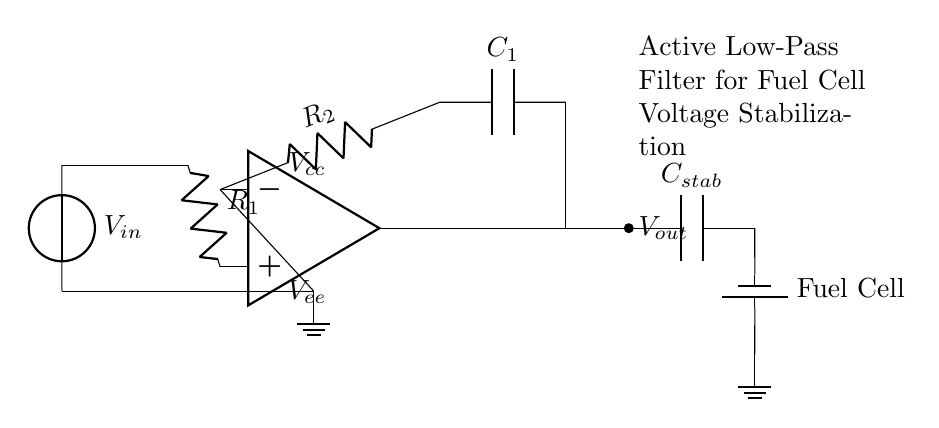What is the input voltage labeled in the circuit? The input voltage is labeled as V_in, which is typically the voltage supplied to the filter circuit.
Answer: V_in What are the components in the feedback network? The feedback network contains a resistor labeled R_2 and a capacitor labeled C_1, showing the components involved in feedback stabilization.
Answer: R_2, C_1 What is the output voltage of this circuit? The output voltage is labeled as V_out, indicating the voltage that is produced by the filter after processing the input voltage.
Answer: V_out What is the function of the capacitor labeled C_stab? C_stab is used for stabilization of the output voltage, ensuring that the voltage remains constant during operation.
Answer: Stabilization How does the circuit stabilize the voltage from the fuel cell? The circuit uses an op-amp in conjunction with resistors and capacitors to create an active low-pass filter, which smooths out fluctuations and stabilizes the output voltage level from the fuel cell.
Answer: Active low-pass filter What voltage rail is provided to the op-amp? The op-amp is connected to a positive voltage rail labeled V_cc, which supplies power to the operational amplifier for its operation.
Answer: V_cc What is the ground reference for this circuit? The ground reference is indicated with a ground symbol connected to the negative input of the op-amp, establishing a common return path for current in the circuit.
Answer: Ground 